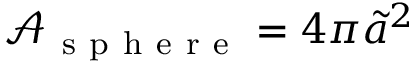<formula> <loc_0><loc_0><loc_500><loc_500>\mathcal { A } _ { s p h e r e } = 4 \pi \tilde { a } ^ { 2 }</formula> 